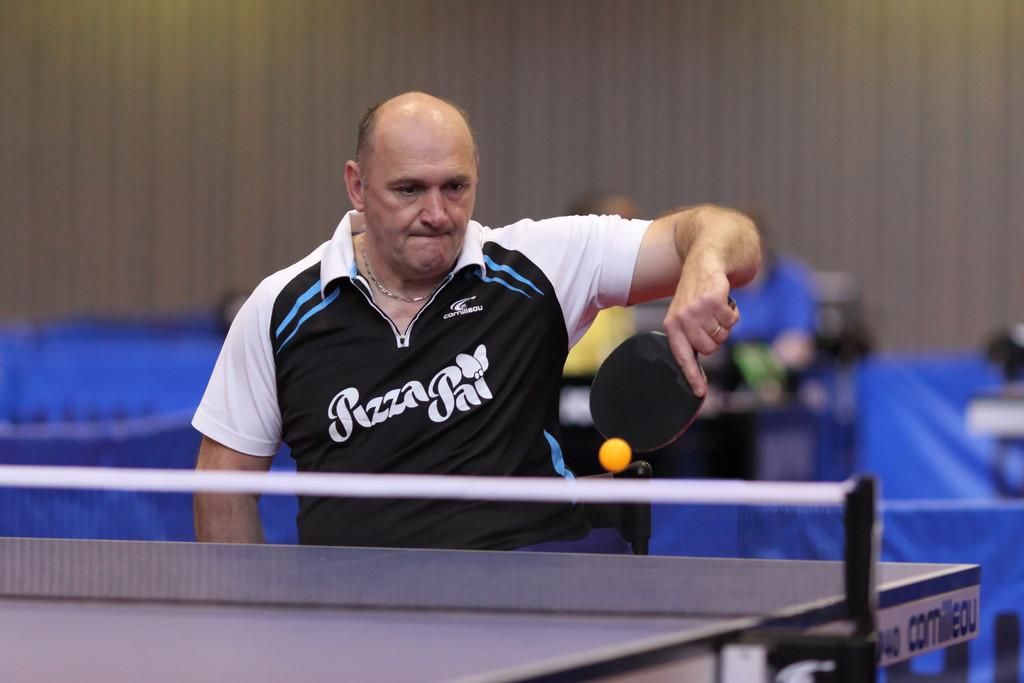Who is the main subject in the image? There is a man in the image. What is the man wearing? The man is wearing a black and white t-shirt. What activity is the man engaged in? The man is playing table tennis. Can you describe the background of the image? The background of the image is blurred. What type of quilt is draped over the table in the image? There is no quilt present in the image; it features a man playing table tennis with a blurred background. 